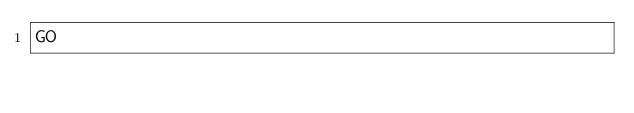<code> <loc_0><loc_0><loc_500><loc_500><_SQL_>GO</code> 